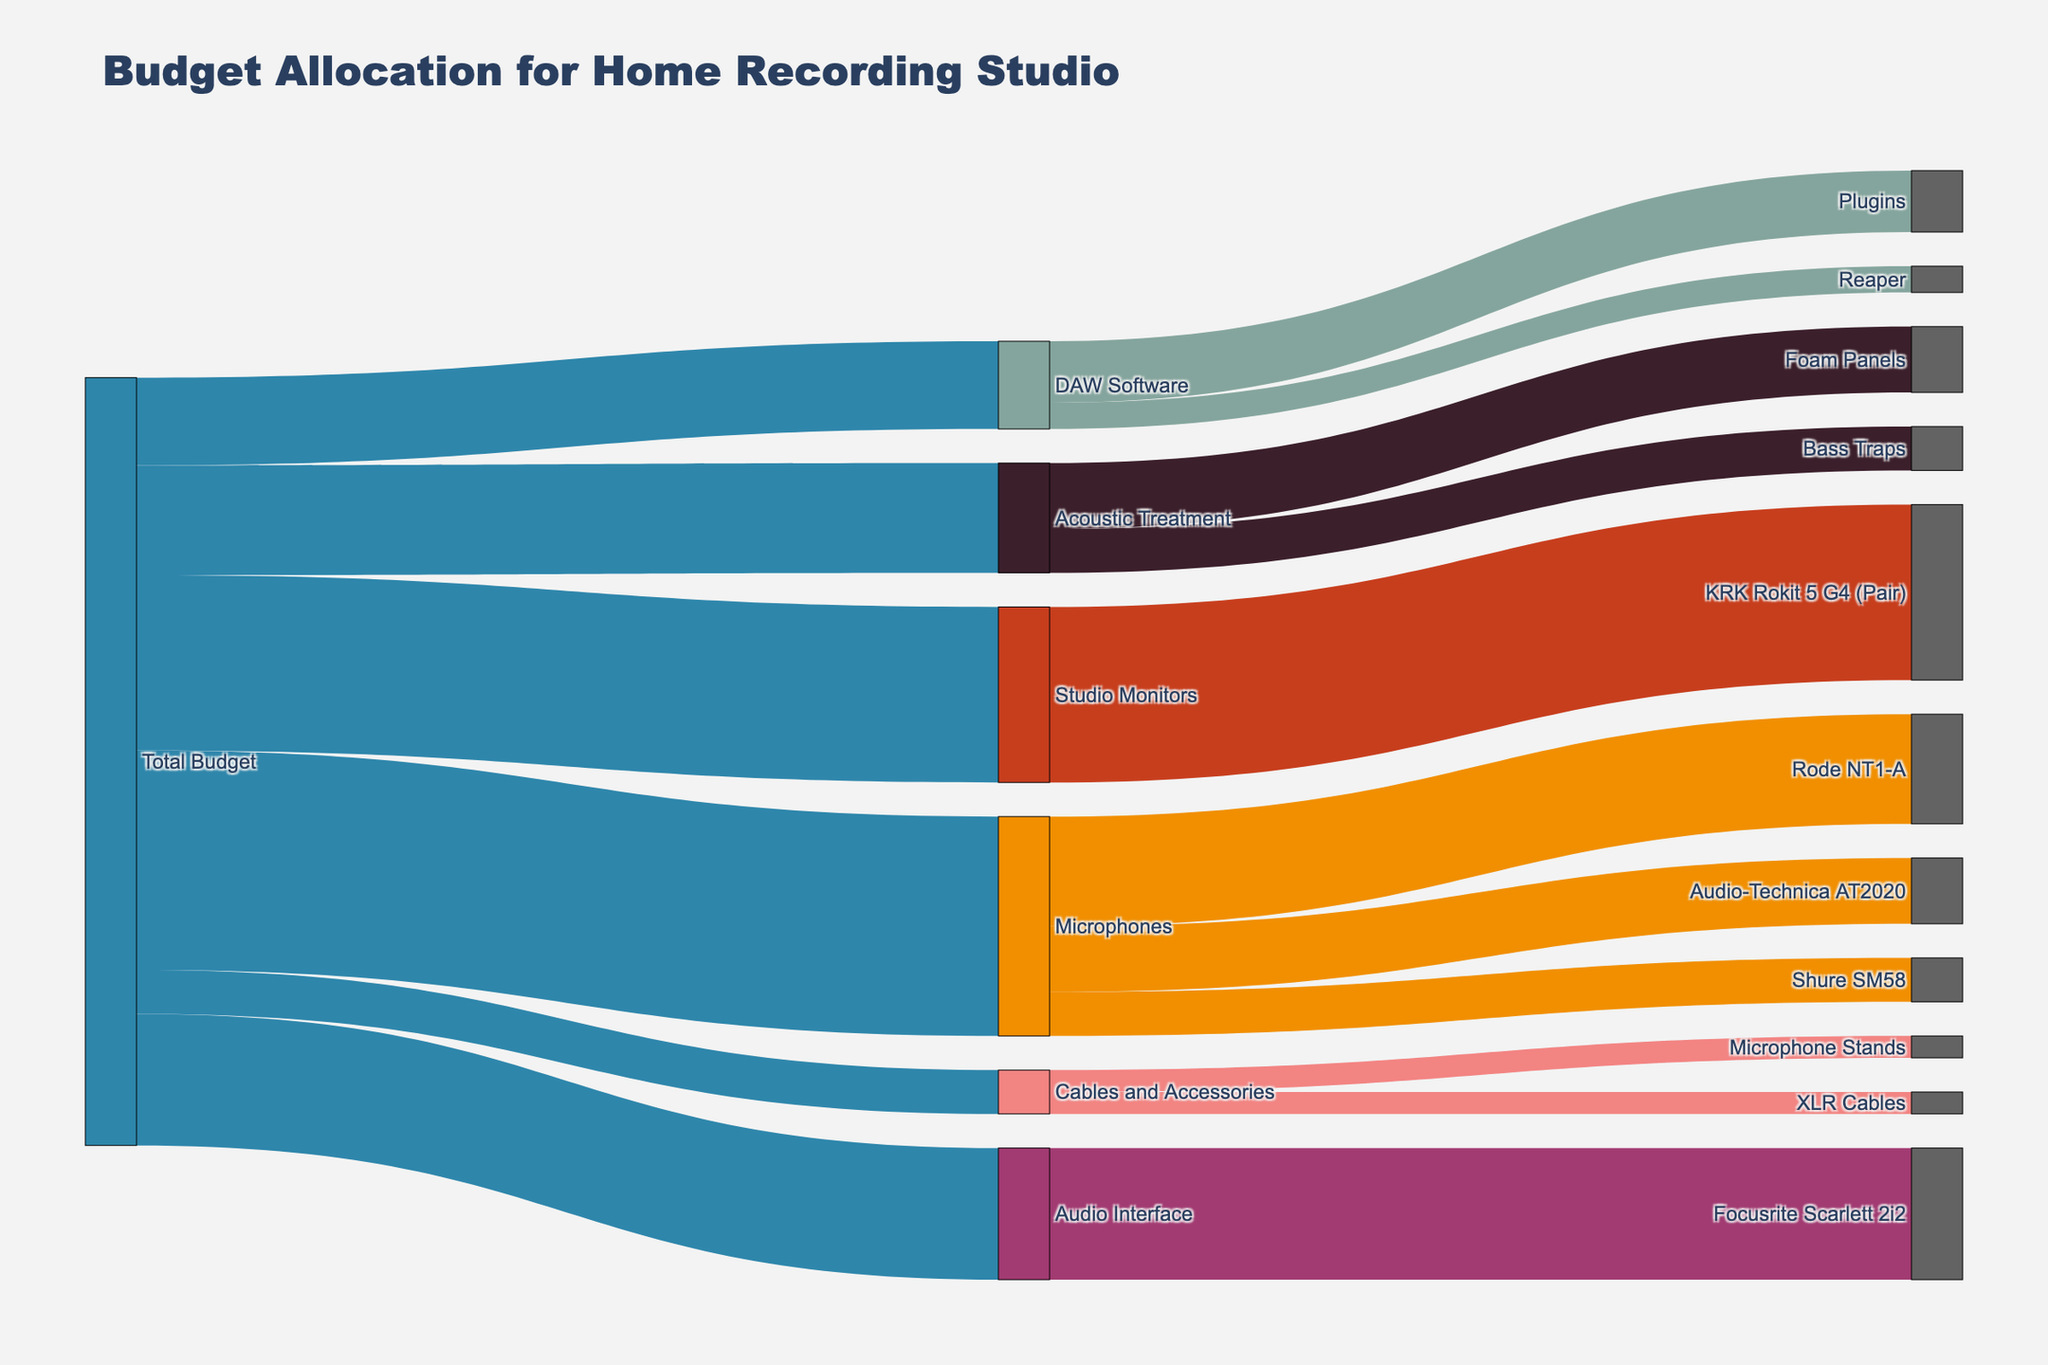Who received the largest portion of the Total Budget? The diagram shows the Total Budget splitting into multiple categories, and the category with the highest value from Total Budget is identified. Microphones, at $500, is the highest allocation.
Answer: Microphones How much budget is allocated to DAW Software? By looking at the section where the Total Budget is split into components, the allocation for DAW Software can be seen.
Answer: 200 What is the total amount spent on Cables and Accessories? The diagram indicates that Cables and Accessories receives $100 from the total budget. Additionally, it later splits into XLR Cables and Microphone Stands, summing these values (50 + 50) confirms it.
Answer: 100 What is the combined budget for Acoustic Treatment and Studio Monitors? The value for Acoustic Treatment is $250 and for Studio Monitors is $400. Adding these together gives the combined budget.
Answer: 650 Which individual microphone has the highest cost? Microphones are further broken down into Shure SM58, Audio-Technica AT2020, and Rode NT1-A. From the values shown, Rode NT1-A is the highest at $250.
Answer: Rode NT1-A Is more budget allocated to Audio Interface or DAW Software? Audio Interface is allocated $300, while DAW Software is allocated $200. Comparing these two values, Audio Interface has a higher value.
Answer: Audio Interface What is the total budget spent on microphones? Summing the individual values allocated to Shure SM58 ($100), Audio-Technica AT2020 ($150), and Rode NT1-A ($250) gives the total budget spent on microphones.
Answer: 500 Which component has a lower budget: Acoustic Treatment or Cables and Accessories? Acoustic Treatment is allocated $250 while Cables and Accessories is allocated $100. Therefore, Cables and Accessories has a lower budget.
Answer: Cables and Accessories How much budget is allocated to Reaper software specifically under DAW Software? Under the DAW Software category, it is split into Reaper and Plugins. The value next to Reaper is $60.
Answer: 60 Which two items have an equal budget allocation? The diagram shows that XLR Cables and Microphone Stands each have $50 allocated to them.
Answer: XLR Cables and Microphone Stands 